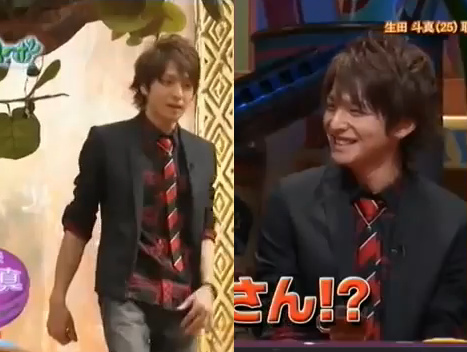Is the coat blue? Yes, the coat is blue. 